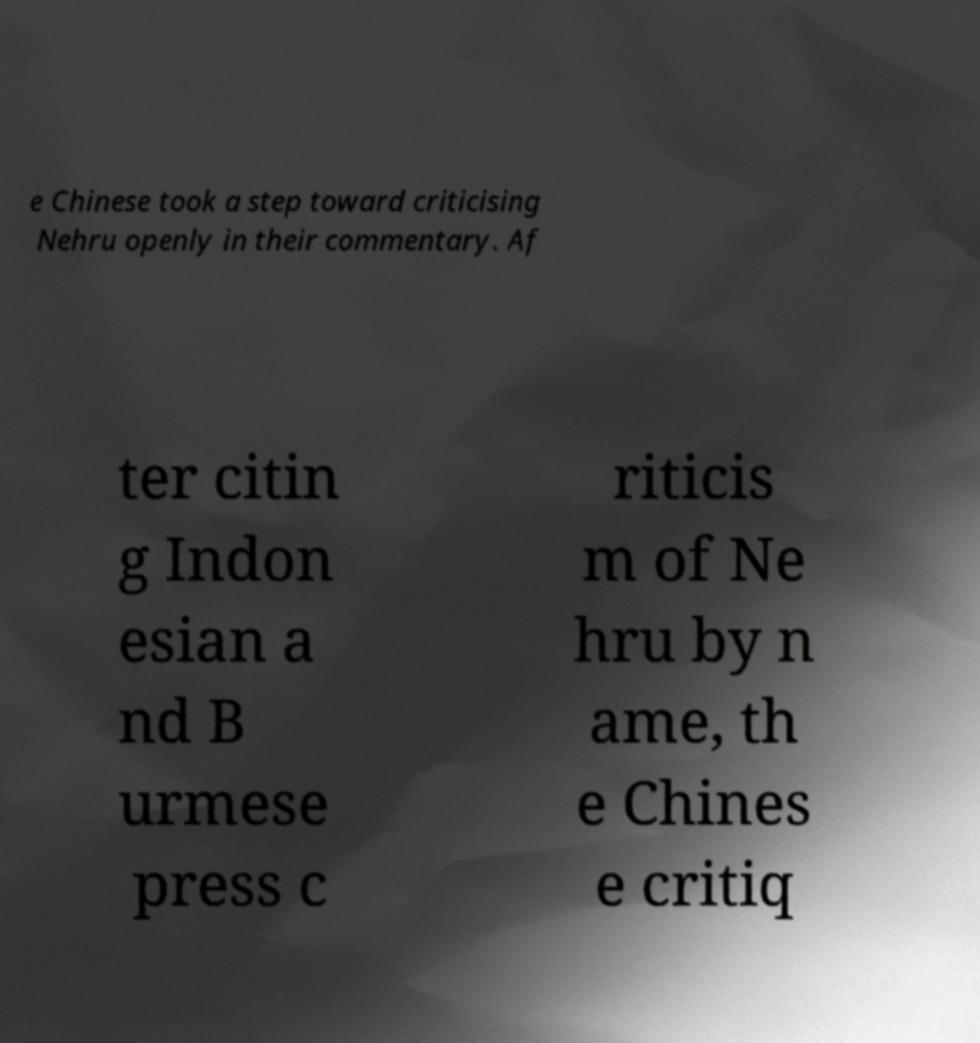What messages or text are displayed in this image? I need them in a readable, typed format. e Chinese took a step toward criticising Nehru openly in their commentary. Af ter citin g Indon esian a nd B urmese press c riticis m of Ne hru by n ame, th e Chines e critiq 